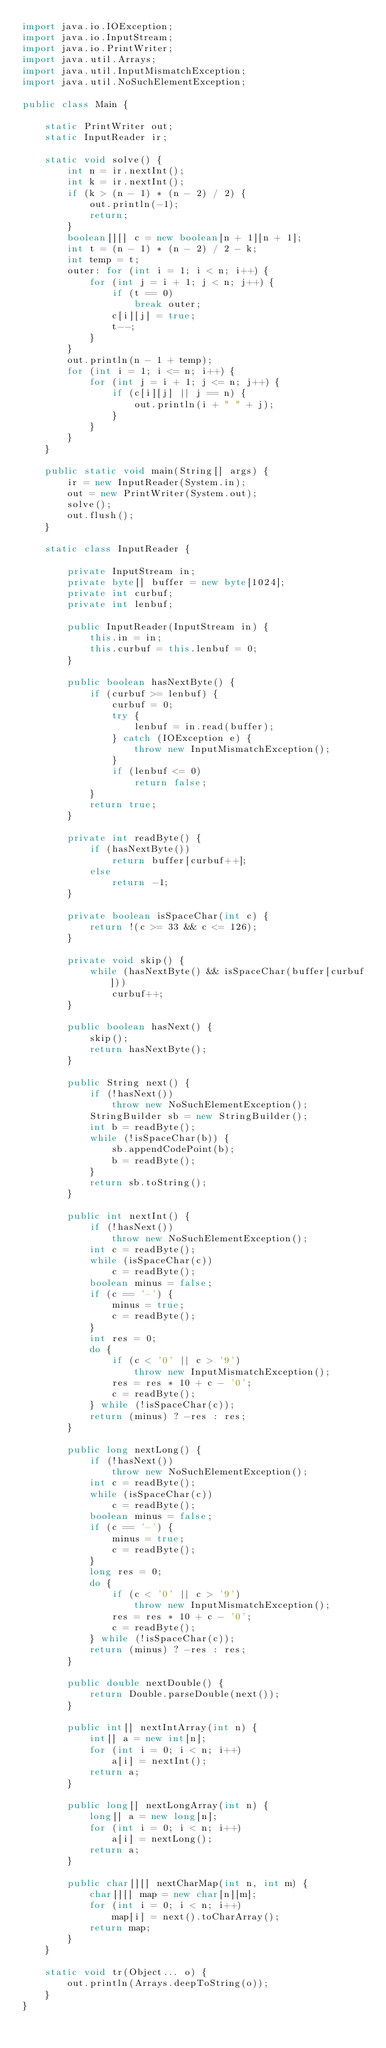Convert code to text. <code><loc_0><loc_0><loc_500><loc_500><_Java_>import java.io.IOException;
import java.io.InputStream;
import java.io.PrintWriter;
import java.util.Arrays;
import java.util.InputMismatchException;
import java.util.NoSuchElementException;

public class Main {

	static PrintWriter out;
	static InputReader ir;

	static void solve() {
		int n = ir.nextInt();
		int k = ir.nextInt();
		if (k > (n - 1) * (n - 2) / 2) {
			out.println(-1);
			return;
		}
		boolean[][] c = new boolean[n + 1][n + 1];
		int t = (n - 1) * (n - 2) / 2 - k;
		int temp = t;
		outer: for (int i = 1; i < n; i++) {
			for (int j = i + 1; j < n; j++) {
				if (t == 0)
					break outer;
				c[i][j] = true;
				t--;
			}
		}
		out.println(n - 1 + temp);
		for (int i = 1; i <= n; i++) {
			for (int j = i + 1; j <= n; j++) {
				if (c[i][j] || j == n) {
					out.println(i + " " + j);
				}
			}
		}
	}

	public static void main(String[] args) {
		ir = new InputReader(System.in);
		out = new PrintWriter(System.out);
		solve();
		out.flush();
	}

	static class InputReader {

		private InputStream in;
		private byte[] buffer = new byte[1024];
		private int curbuf;
		private int lenbuf;

		public InputReader(InputStream in) {
			this.in = in;
			this.curbuf = this.lenbuf = 0;
		}

		public boolean hasNextByte() {
			if (curbuf >= lenbuf) {
				curbuf = 0;
				try {
					lenbuf = in.read(buffer);
				} catch (IOException e) {
					throw new InputMismatchException();
				}
				if (lenbuf <= 0)
					return false;
			}
			return true;
		}

		private int readByte() {
			if (hasNextByte())
				return buffer[curbuf++];
			else
				return -1;
		}

		private boolean isSpaceChar(int c) {
			return !(c >= 33 && c <= 126);
		}

		private void skip() {
			while (hasNextByte() && isSpaceChar(buffer[curbuf]))
				curbuf++;
		}

		public boolean hasNext() {
			skip();
			return hasNextByte();
		}

		public String next() {
			if (!hasNext())
				throw new NoSuchElementException();
			StringBuilder sb = new StringBuilder();
			int b = readByte();
			while (!isSpaceChar(b)) {
				sb.appendCodePoint(b);
				b = readByte();
			}
			return sb.toString();
		}

		public int nextInt() {
			if (!hasNext())
				throw new NoSuchElementException();
			int c = readByte();
			while (isSpaceChar(c))
				c = readByte();
			boolean minus = false;
			if (c == '-') {
				minus = true;
				c = readByte();
			}
			int res = 0;
			do {
				if (c < '0' || c > '9')
					throw new InputMismatchException();
				res = res * 10 + c - '0';
				c = readByte();
			} while (!isSpaceChar(c));
			return (minus) ? -res : res;
		}

		public long nextLong() {
			if (!hasNext())
				throw new NoSuchElementException();
			int c = readByte();
			while (isSpaceChar(c))
				c = readByte();
			boolean minus = false;
			if (c == '-') {
				minus = true;
				c = readByte();
			}
			long res = 0;
			do {
				if (c < '0' || c > '9')
					throw new InputMismatchException();
				res = res * 10 + c - '0';
				c = readByte();
			} while (!isSpaceChar(c));
			return (minus) ? -res : res;
		}

		public double nextDouble() {
			return Double.parseDouble(next());
		}

		public int[] nextIntArray(int n) {
			int[] a = new int[n];
			for (int i = 0; i < n; i++)
				a[i] = nextInt();
			return a;
		}

		public long[] nextLongArray(int n) {
			long[] a = new long[n];
			for (int i = 0; i < n; i++)
				a[i] = nextLong();
			return a;
		}

		public char[][] nextCharMap(int n, int m) {
			char[][] map = new char[n][m];
			for (int i = 0; i < n; i++)
				map[i] = next().toCharArray();
			return map;
		}
	}

	static void tr(Object... o) {
		out.println(Arrays.deepToString(o));
	}
}
</code> 